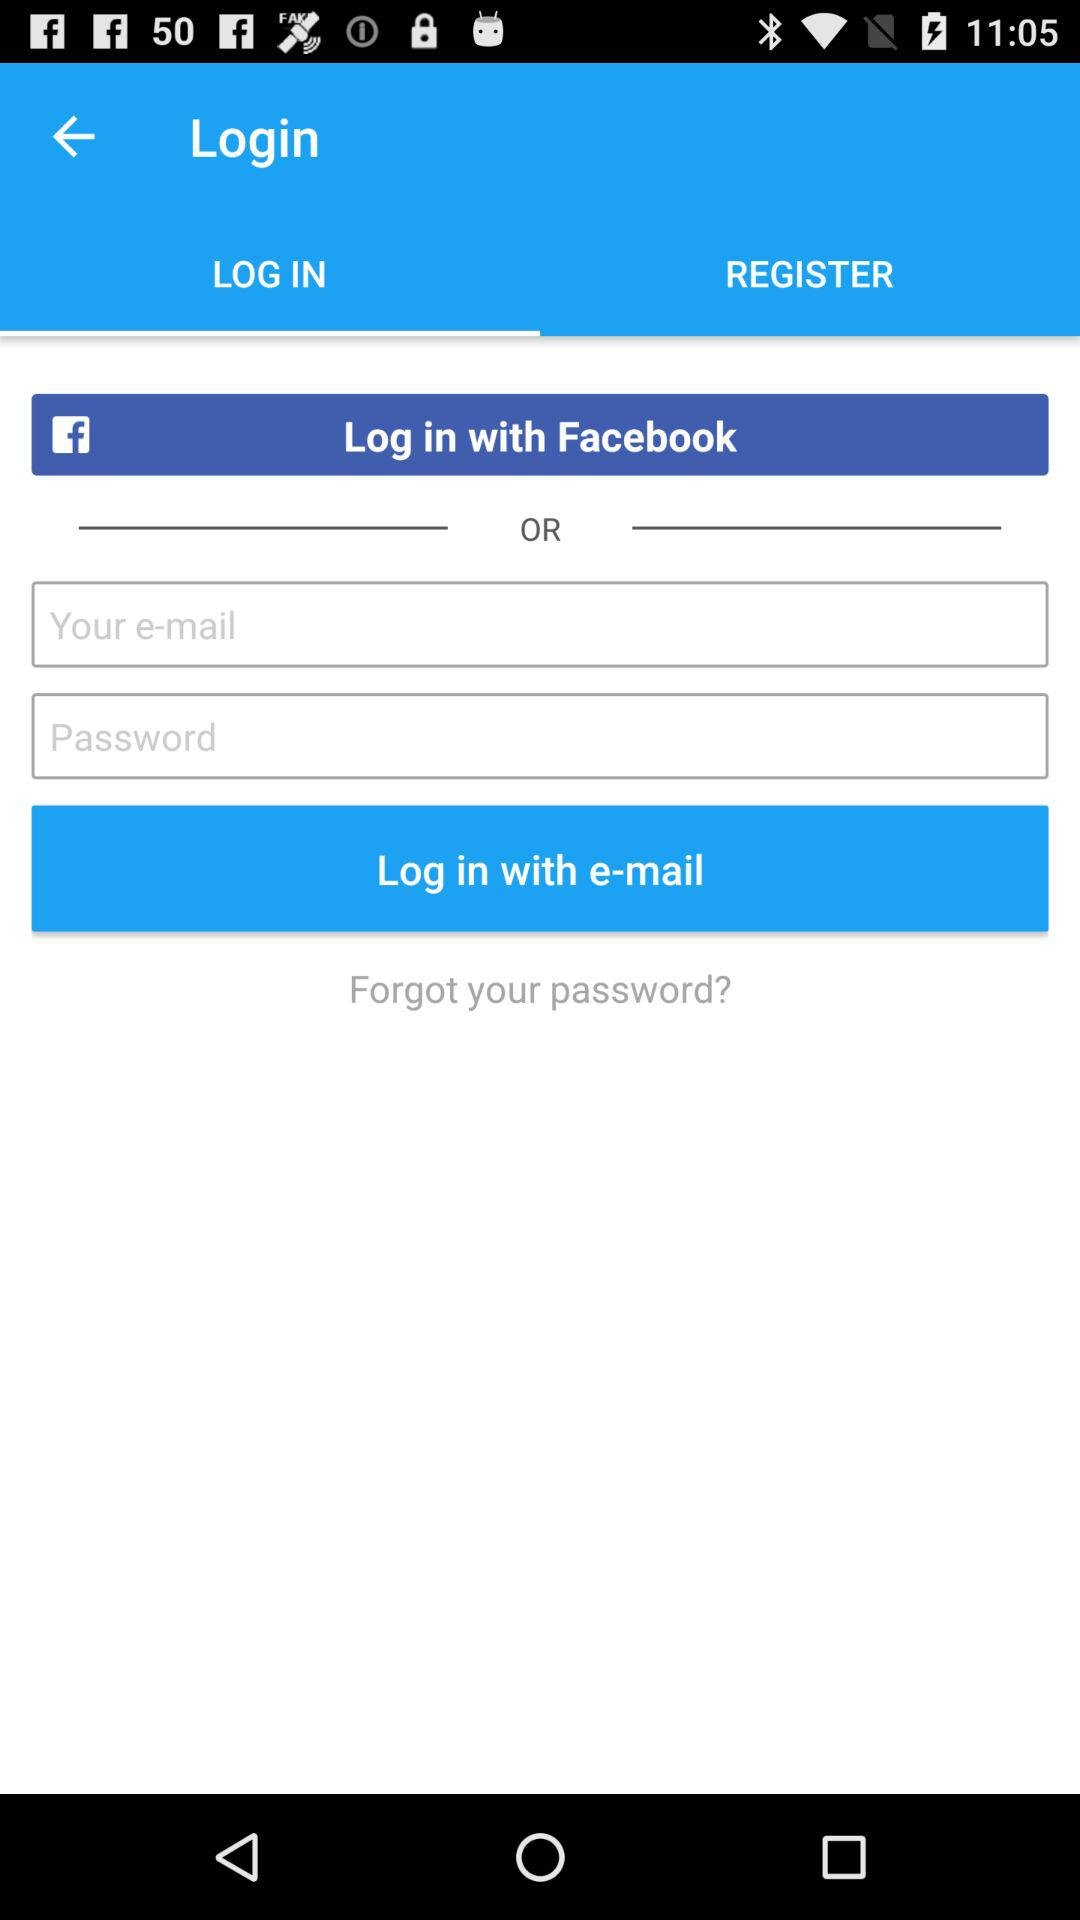Which tab is selected? The selected tab is "LOG IN". 